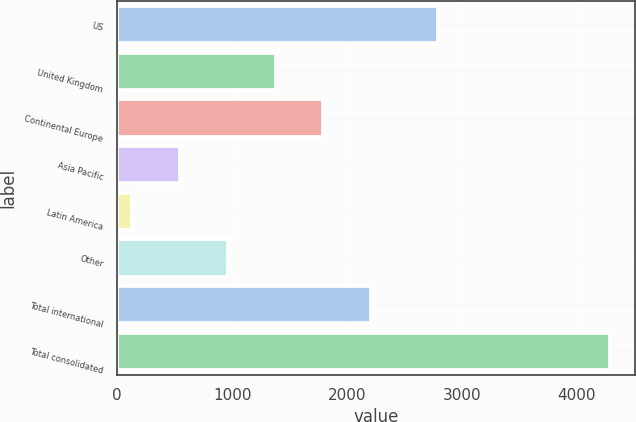<chart> <loc_0><loc_0><loc_500><loc_500><bar_chart><fcel>US<fcel>United Kingdom<fcel>Continental Europe<fcel>Asia Pacific<fcel>Latin America<fcel>Other<fcel>Total international<fcel>Total consolidated<nl><fcel>2797.3<fcel>1379.17<fcel>1795.36<fcel>546.79<fcel>130.6<fcel>962.98<fcel>2211.55<fcel>4292.5<nl></chart> 